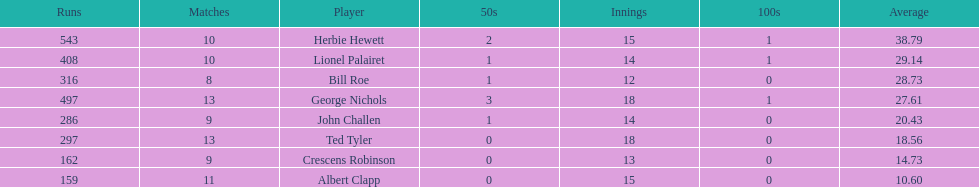How many innings did bill and ted have in total? 30. 